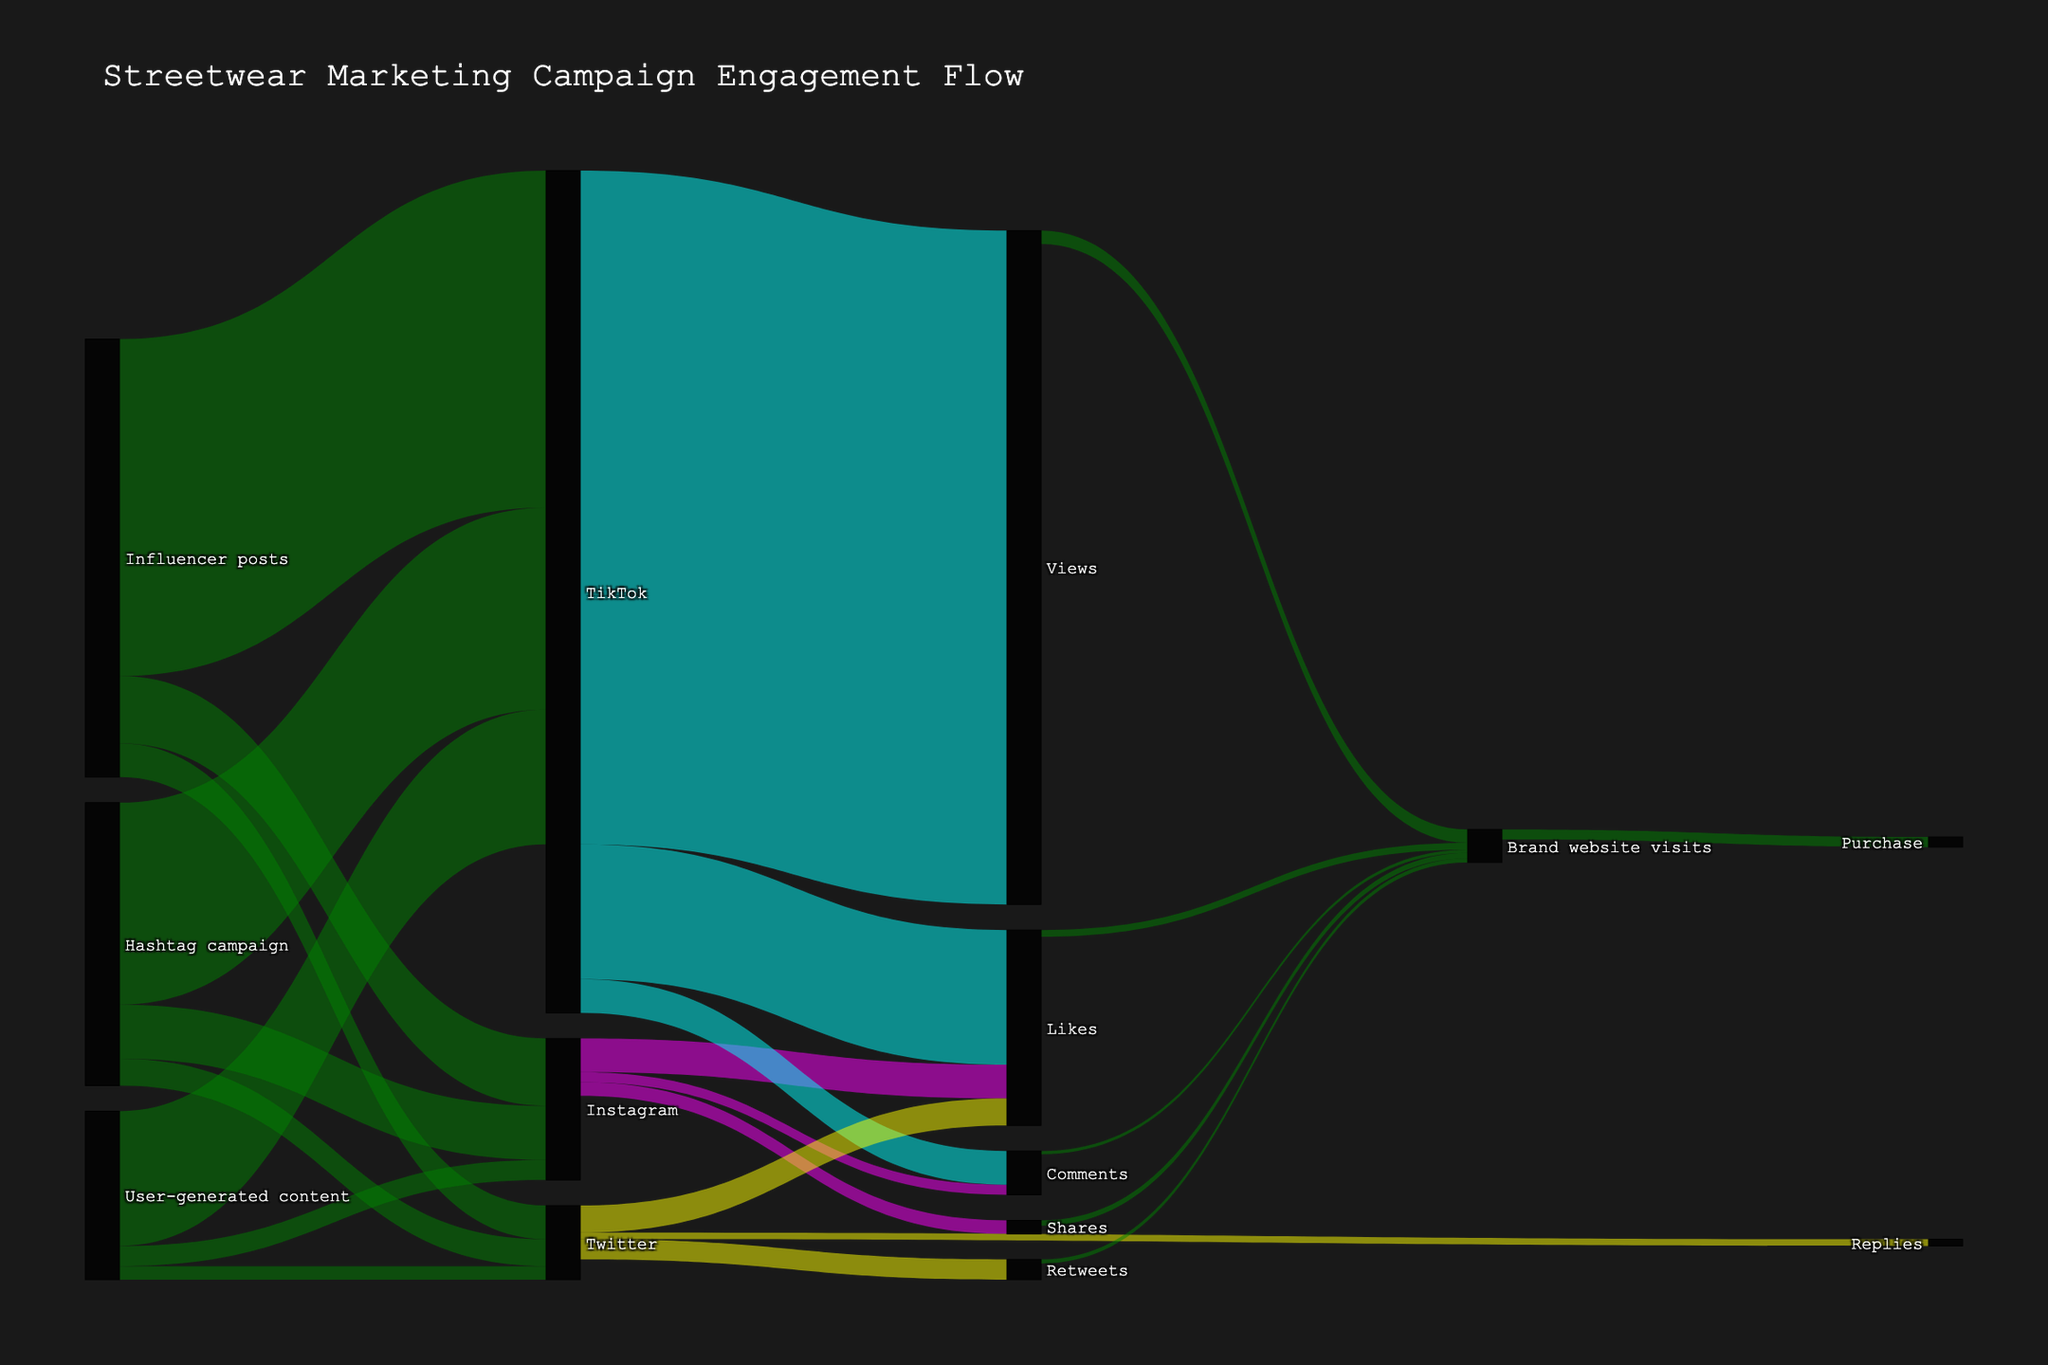What's the title of the figure? The title of the figure is prominently displayed at the top.
Answer: Streetwear Marketing Campaign Engagement Flow Which social media platform generated the most likes from influencer posts? By looking at the flows from "Influencer posts" to each platform, TikTok shows the largest flow for likes.
Answer: TikTok What is the total number of likes generated on all platforms? Add the values for Likes across all platforms: Instagram (50,000), TikTok (200,000), and Twitter (40,000). 50,000 + 200,000 + 40,000 = 290,000.
Answer: 290,000 Which engagement type on Instagram leads to the highest number of subsequent brand website visits? Compare the flows from Instagram to brand website visits for Likes, Comments, and Shares. The highest value is for Likes (10,000 visits).
Answer: Likes What is the combined number of purchases made after visiting the brand website? Refer to the flow from "Brand website visits" to "Purchase," which shows a value of 15,000.
Answer: 15,000 Which platform had the highest number of interactions generated by the hashtag campaign? Compare the flows from "Hashtag campaign" to each platform. TikTok (300,000) has the highest value compared to Instagram and Twitter.
Answer: TikTok How many total views on TikTok led to brand website visits? Refer to the flow from "Views" under TikTok to "Brand website visits," which shows a value of 20,000.
Answer: 20,000 Arrange the social media platforms in descending order of comments generated. Comparing the target values for "Comments": TikTok (50,000), Instagram (15,000), and Twitter (10,000). Order them from highest to lowest.
Answer: TikTok, Instagram, Twitter What is the total number of social media interactions initiated by user-generated content? Sum the values flowing from "User-generated content" to each platform: Instagram (30,000) + TikTok (200,000) + Twitter (20,000) = 250,000.
Answer: 250,000 